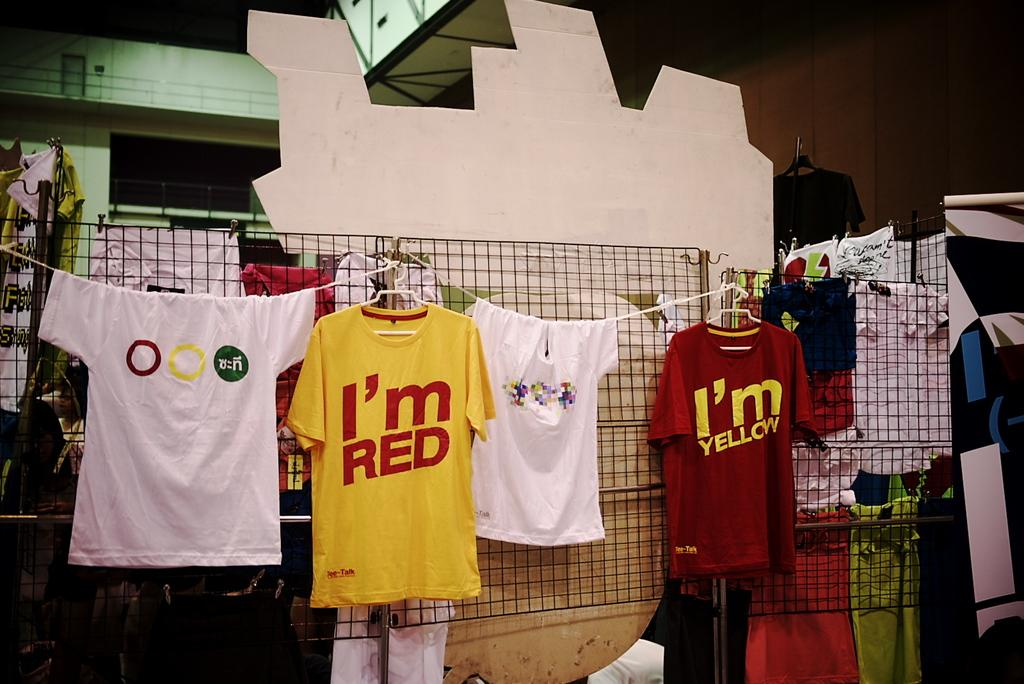<image>
Summarize the visual content of the image. several shirts for sale on a line like ones saying I'm RED 